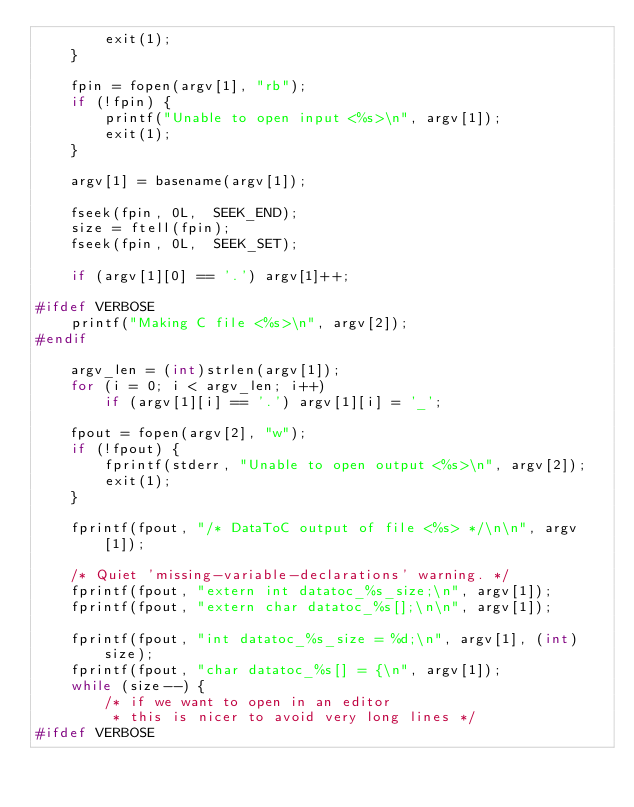Convert code to text. <code><loc_0><loc_0><loc_500><loc_500><_C_>		exit(1);
	}

	fpin = fopen(argv[1], "rb");
	if (!fpin) {
		printf("Unable to open input <%s>\n", argv[1]);
		exit(1);
	}

	argv[1] = basename(argv[1]);

	fseek(fpin, 0L,  SEEK_END);
	size = ftell(fpin);
	fseek(fpin, 0L,  SEEK_SET);

	if (argv[1][0] == '.') argv[1]++;

#ifdef VERBOSE
	printf("Making C file <%s>\n", argv[2]);
#endif

	argv_len = (int)strlen(argv[1]);
	for (i = 0; i < argv_len; i++)
		if (argv[1][i] == '.') argv[1][i] = '_';

	fpout = fopen(argv[2], "w");
	if (!fpout) {
		fprintf(stderr, "Unable to open output <%s>\n", argv[2]);
		exit(1);
	}

	fprintf(fpout, "/* DataToC output of file <%s> */\n\n", argv[1]);

	/* Quiet 'missing-variable-declarations' warning. */
	fprintf(fpout, "extern int datatoc_%s_size;\n", argv[1]);
	fprintf(fpout, "extern char datatoc_%s[];\n\n", argv[1]);

	fprintf(fpout, "int datatoc_%s_size = %d;\n", argv[1], (int)size);
	fprintf(fpout, "char datatoc_%s[] = {\n", argv[1]);
	while (size--) {
		/* if we want to open in an editor
		 * this is nicer to avoid very long lines */
#ifdef VERBOSE</code> 